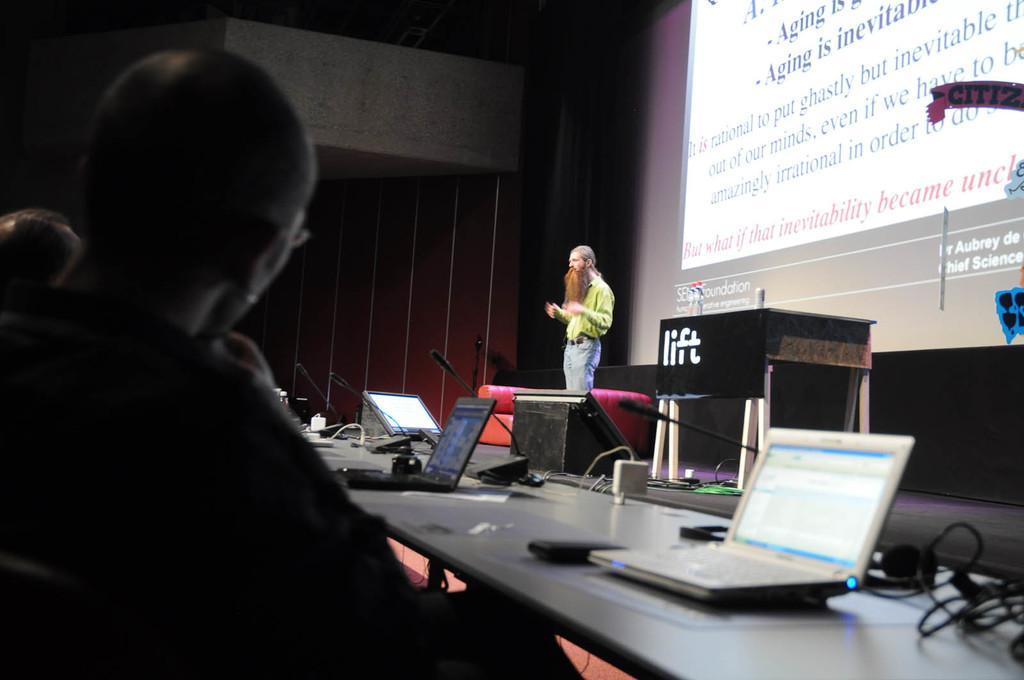How would you summarize this image in a sentence or two? This persons are sitting on a chair. On this table there is a mobile, laptop, headset and cables. Screen is on wall. This man is standing. This is a red couch. This is podium. On stage there is a table. 